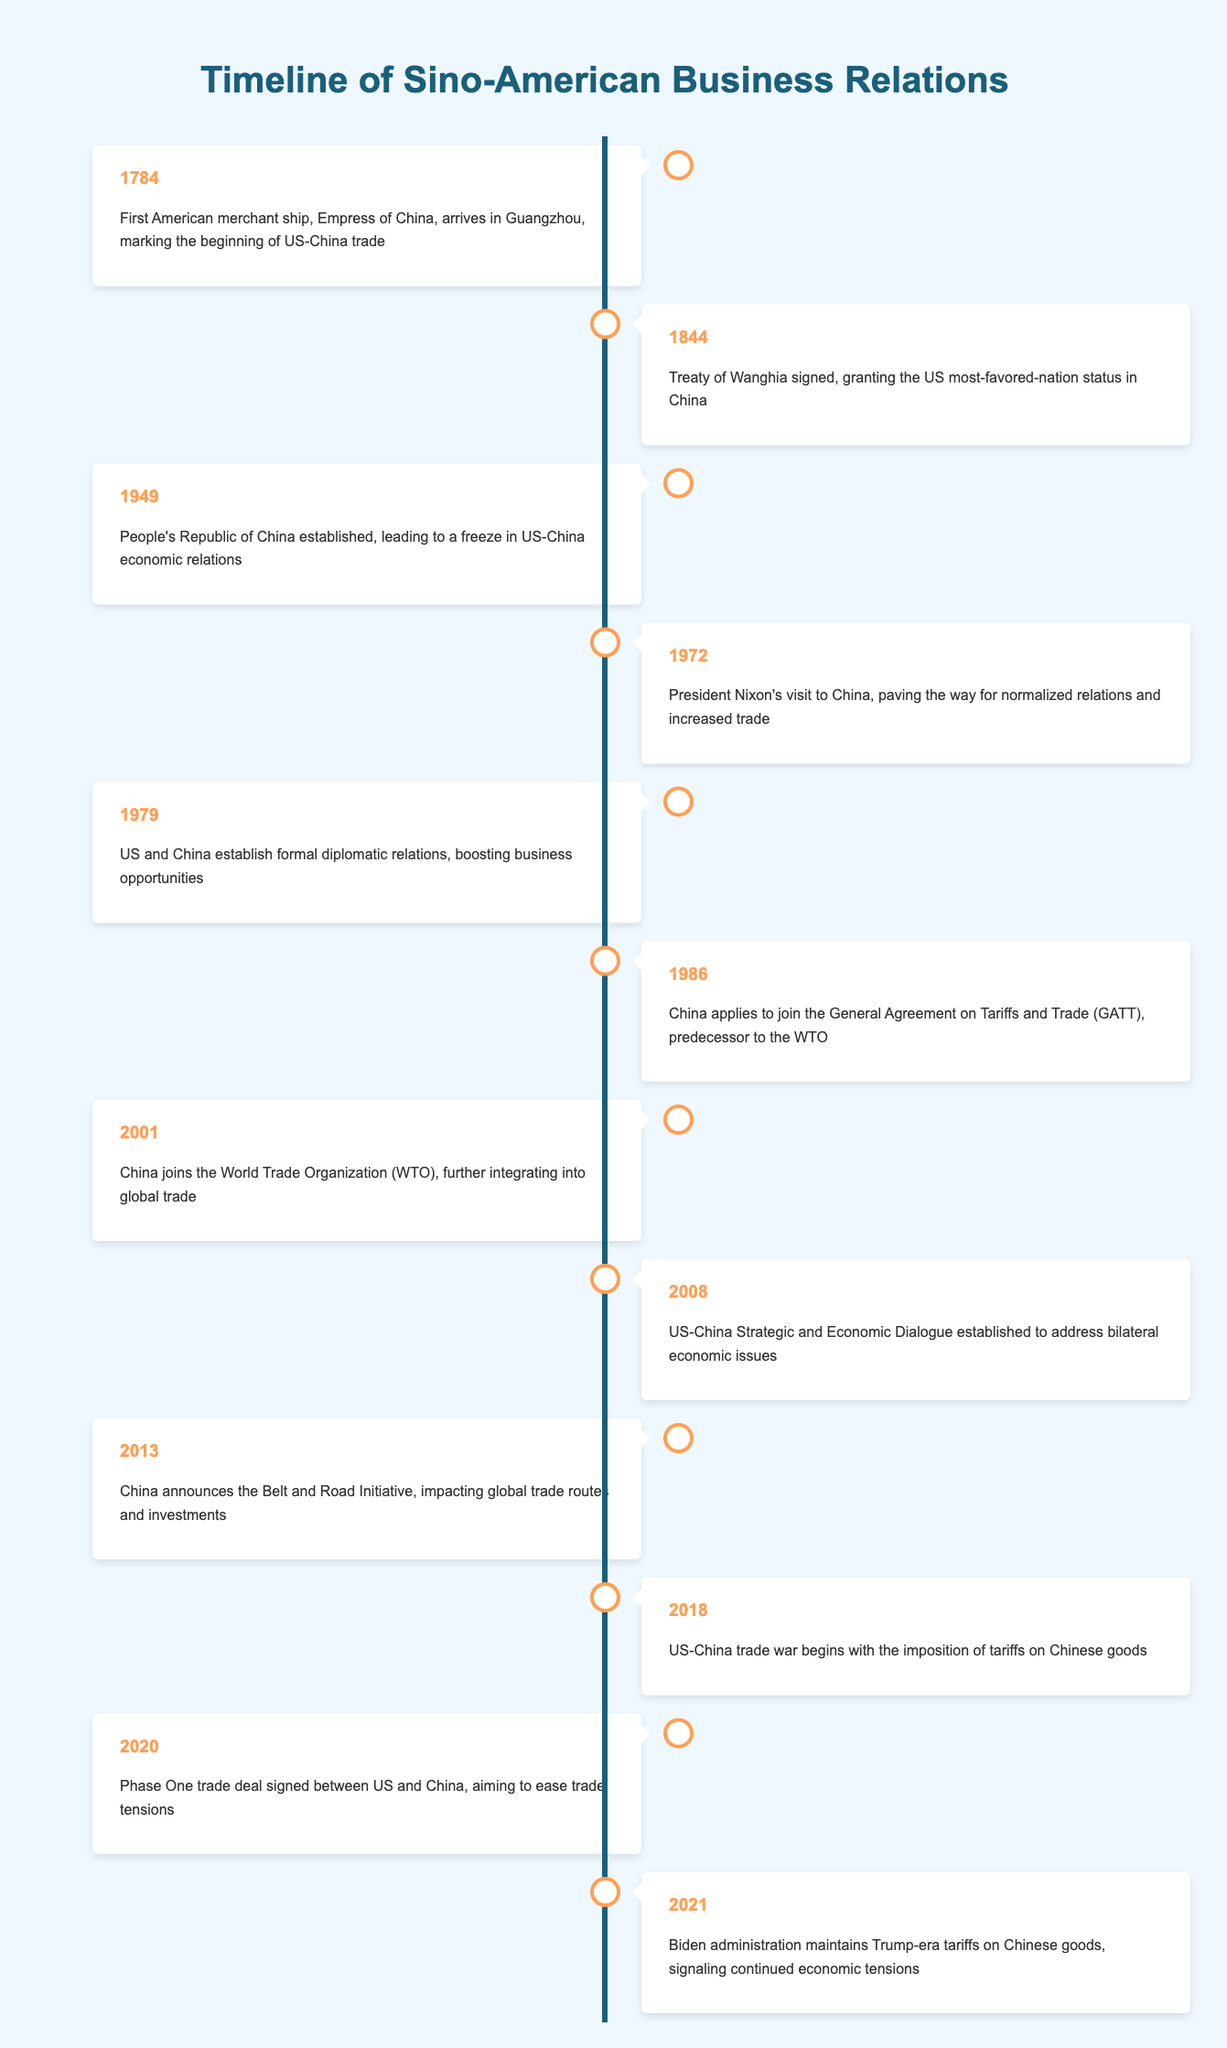What year did the US-China trade war begin? According to the timeline, the US-China trade war began in 2018, which is specified in the event description for that year.
Answer: 2018 What significant event occurred in 1979 related to US-China relations? The timeline indicates that in 1979, the US and China established formal diplomatic relations, which is noted as a significant step that boosted business opportunities.
Answer: Establishment of formal diplomatic relations What is the relationship between the signing of the Treaty of Wanghia and American trade status in China? The Treaty of Wanghia, signed in 1844, granted the US most-favored-nation status in China, suggesting that this treaty was crucial for improving American trading rights in China.
Answer: Most-favored-nation status granted In which year did China join the World Trade Organization? The timeline specifies that China joined the World Trade Organization in 2001, making this a straightforward retrieval question from the table.
Answer: 2001 Did the establishment of the People's Republic of China in 1949 lead to an improvement or freeze in US-China economic relations? According to the timeline, the establishment of the People's Republic of China in 1949 led to a freeze in US-China economic relations, indicating a deterioration rather than improvement.
Answer: Freeze What are the years during which the US and China signed significant trade agreements, specifically regarding entering global trade structures? The timeline shows that China applied to join GATT in 1986 and joined the WTO in 2001, thus both years mark significant agreements related to global trade structures. First, 1986 indicates an application, and later, 2001 confirms membership.
Answer: 1986 and 2001 What was the impact of Nixon's visit to China in 1972 on US-China relations? The event description for 1972 states that Nixon's visit paved the way for normalized relations and increased trade, indicating a positive impact on their relationship.
Answer: Paved the way for normalized relations How many years are there between the establishment of formal diplomatic relations and China's joining the WTO? The establishment of formal diplomatic relations was in 1979 and China joined the WTO in 2001. The difference in years is calculated by subtracting 1979 from 2001, resulting in 22 years.
Answer: 22 years From the timeline, was there a trade deal signed in 2020 to ease tensions? Yes, the timeline confirms that a Phase One trade deal was signed in 2020 between the US and China, aiming to ease trade tensions.
Answer: Yes What were the economic relations like from 1949 until 1972? The description in the timeline indicates that from 1949 (the establishment of the People's Republic of China) until Nixon's visit in 1972, US-China economic relations were frozen, suggesting no progress in trade or economic interactions.
Answer: Frozen economic relations 